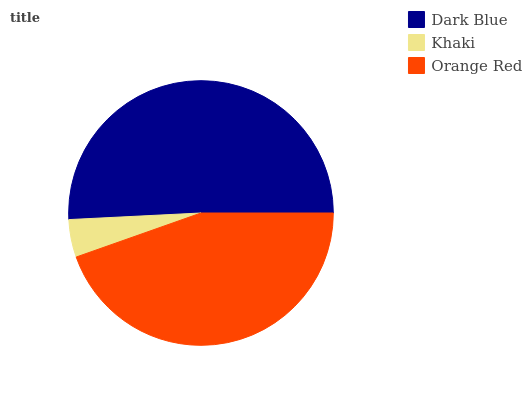Is Khaki the minimum?
Answer yes or no. Yes. Is Dark Blue the maximum?
Answer yes or no. Yes. Is Orange Red the minimum?
Answer yes or no. No. Is Orange Red the maximum?
Answer yes or no. No. Is Orange Red greater than Khaki?
Answer yes or no. Yes. Is Khaki less than Orange Red?
Answer yes or no. Yes. Is Khaki greater than Orange Red?
Answer yes or no. No. Is Orange Red less than Khaki?
Answer yes or no. No. Is Orange Red the high median?
Answer yes or no. Yes. Is Orange Red the low median?
Answer yes or no. Yes. Is Dark Blue the high median?
Answer yes or no. No. Is Khaki the low median?
Answer yes or no. No. 